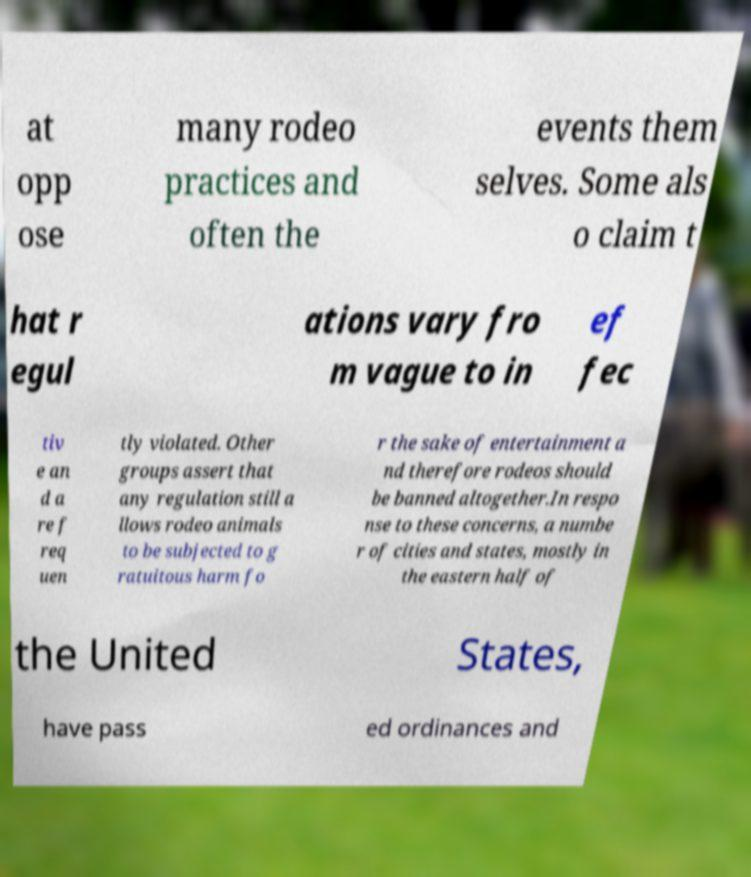There's text embedded in this image that I need extracted. Can you transcribe it verbatim? at opp ose many rodeo practices and often the events them selves. Some als o claim t hat r egul ations vary fro m vague to in ef fec tiv e an d a re f req uen tly violated. Other groups assert that any regulation still a llows rodeo animals to be subjected to g ratuitous harm fo r the sake of entertainment a nd therefore rodeos should be banned altogether.In respo nse to these concerns, a numbe r of cities and states, mostly in the eastern half of the United States, have pass ed ordinances and 